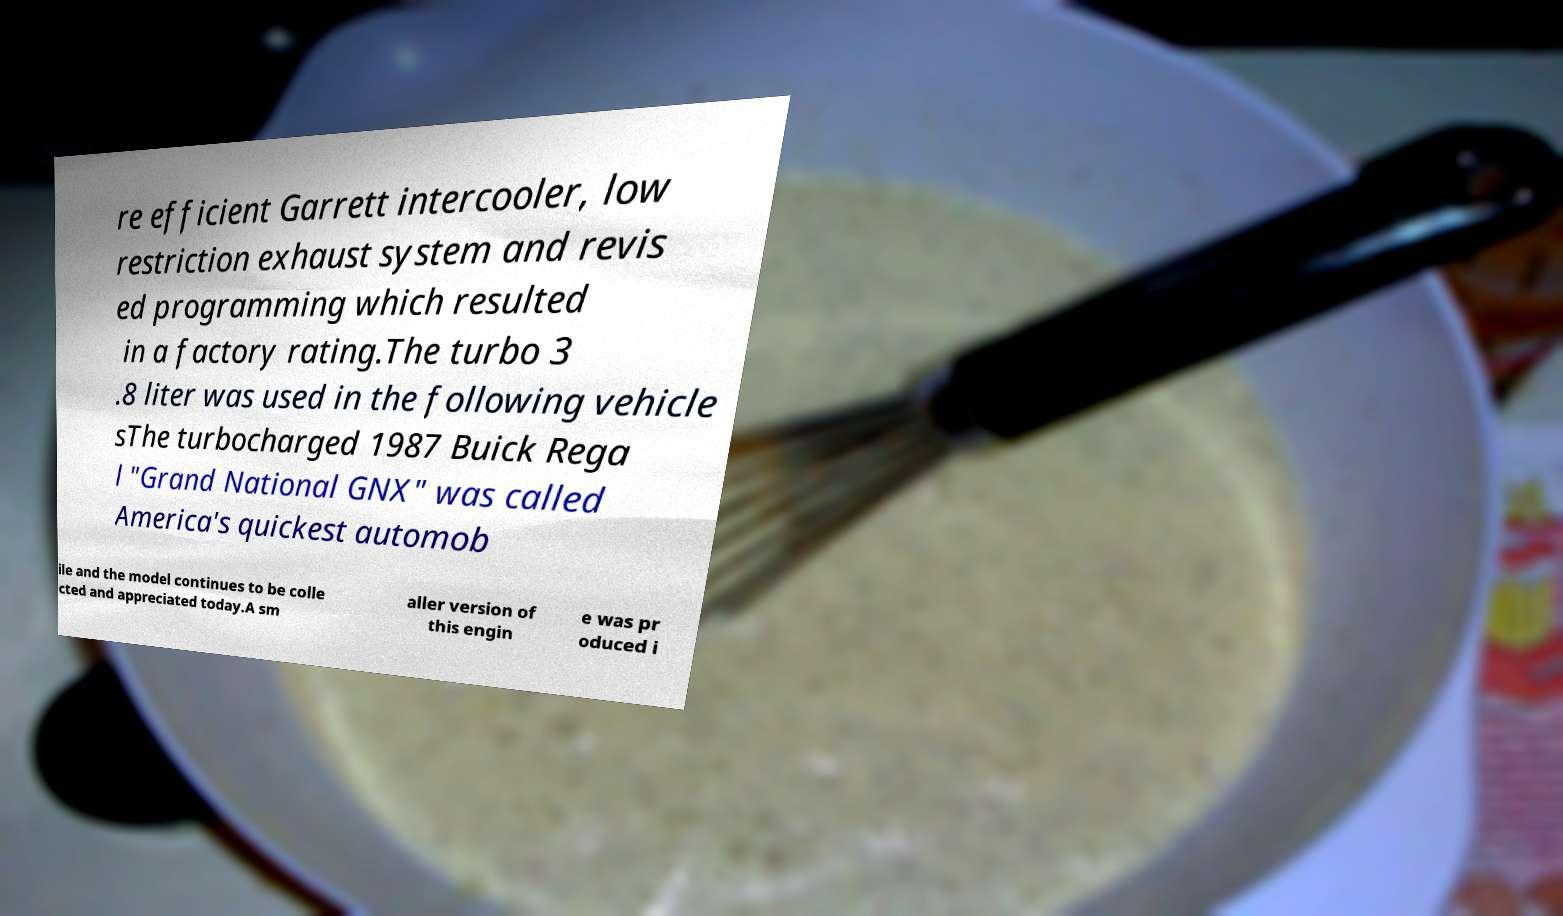Can you read and provide the text displayed in the image?This photo seems to have some interesting text. Can you extract and type it out for me? re efficient Garrett intercooler, low restriction exhaust system and revis ed programming which resulted in a factory rating.The turbo 3 .8 liter was used in the following vehicle sThe turbocharged 1987 Buick Rega l "Grand National GNX" was called America's quickest automob ile and the model continues to be colle cted and appreciated today.A sm aller version of this engin e was pr oduced i 